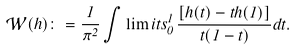<formula> <loc_0><loc_0><loc_500><loc_500>\mathcal { W } ( h ) \colon = \frac { 1 } { \pi ^ { 2 } } \int \lim i t s _ { 0 } ^ { 1 } \, \frac { [ h ( t ) - t h ( 1 ) ] } { t ( 1 - t ) } d t .</formula> 